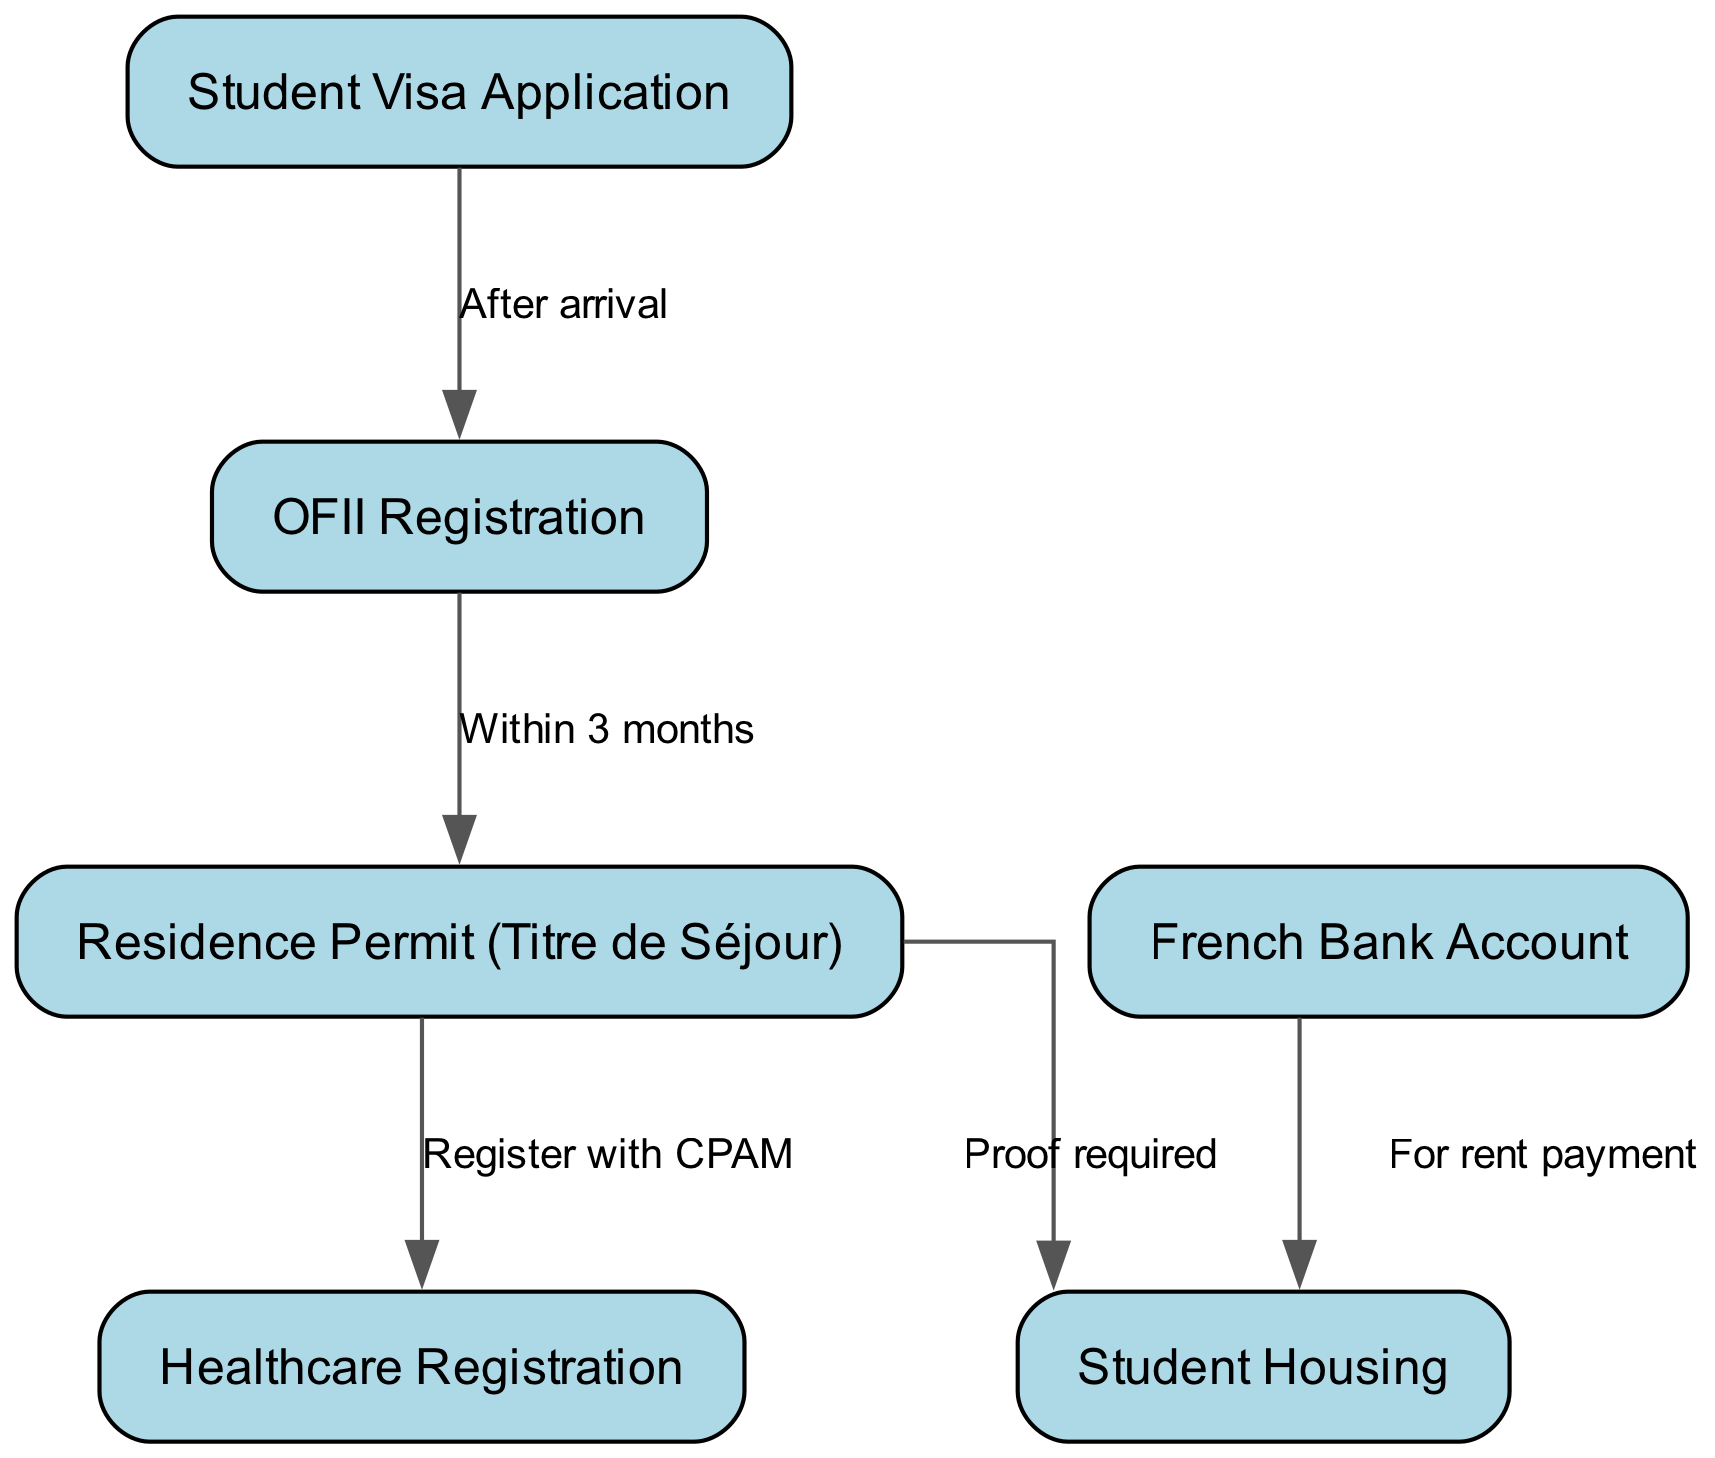What is the first step in the process? The diagram indicates that the first step involves the "Student Visa Application" before any other processes can begin.
Answer: Student Visa Application How many nodes are present in the diagram? By counting the nodes labeled in the diagram, we can identify a total of six nodes: Student Visa Application, Residence Permit, Student Housing, Healthcare Registration, French Bank Account, and OFII Registration.
Answer: 6 What do you need to do within three months after arrival? The diagram states that after arriving in France, you must complete the "OFII Registration" within three months as indicated by the arrow leading from "visa" to "ofii."
Answer: OFII Registration Which document is required to secure housing? The diagram shows that proof of the "Residence Permit" is needed to proceed to the "Student Housing," which establishes that the residence permit is a necessary document for securing housing.
Answer: Residence Permit What must be registered with CPAM? The diagram guides you from "Residence Permit" to "Healthcare Registration," which clearly states that you need to register with CPAM once you have your residence permit.
Answer: Healthcare Registration What is necessary for rent payment? According to the diagram, to secure housing, you must have a "French Bank Account" that is specifically required for making rent payments.
Answer: French Bank Account What is the relationship between "OFII Registration" and "Residence Permit"? The relationship indicated in the diagram shows that after completing OFII Registration, you must apply for the Residence Permit within three months, creating a direct connection between these two steps in the bureaucratic process.
Answer: Within 3 months How does one obtain housing after receiving a residence permit? The diagram specifies that you need to provide proof of the Residence Permit to secure Student Housing, which indicates that this is the necessary step to take after receiving the permit in the bureaucratic process.
Answer: Proof required What step links the French Bank Account to housing? The diagram illustrates that there is a direct connection from "French Bank Account" to "Student Housing," indicating that having a bank account is necessary specifically for making rent payments.
Answer: For rent payment 